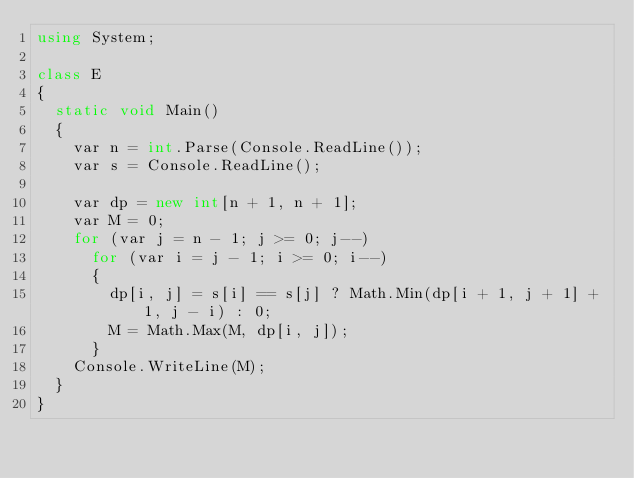<code> <loc_0><loc_0><loc_500><loc_500><_C#_>using System;

class E
{
	static void Main()
	{
		var n = int.Parse(Console.ReadLine());
		var s = Console.ReadLine();

		var dp = new int[n + 1, n + 1];
		var M = 0;
		for (var j = n - 1; j >= 0; j--)
			for (var i = j - 1; i >= 0; i--)
			{
				dp[i, j] = s[i] == s[j] ? Math.Min(dp[i + 1, j + 1] + 1, j - i) : 0;
				M = Math.Max(M, dp[i, j]);
			}
		Console.WriteLine(M);
	}
}
</code> 